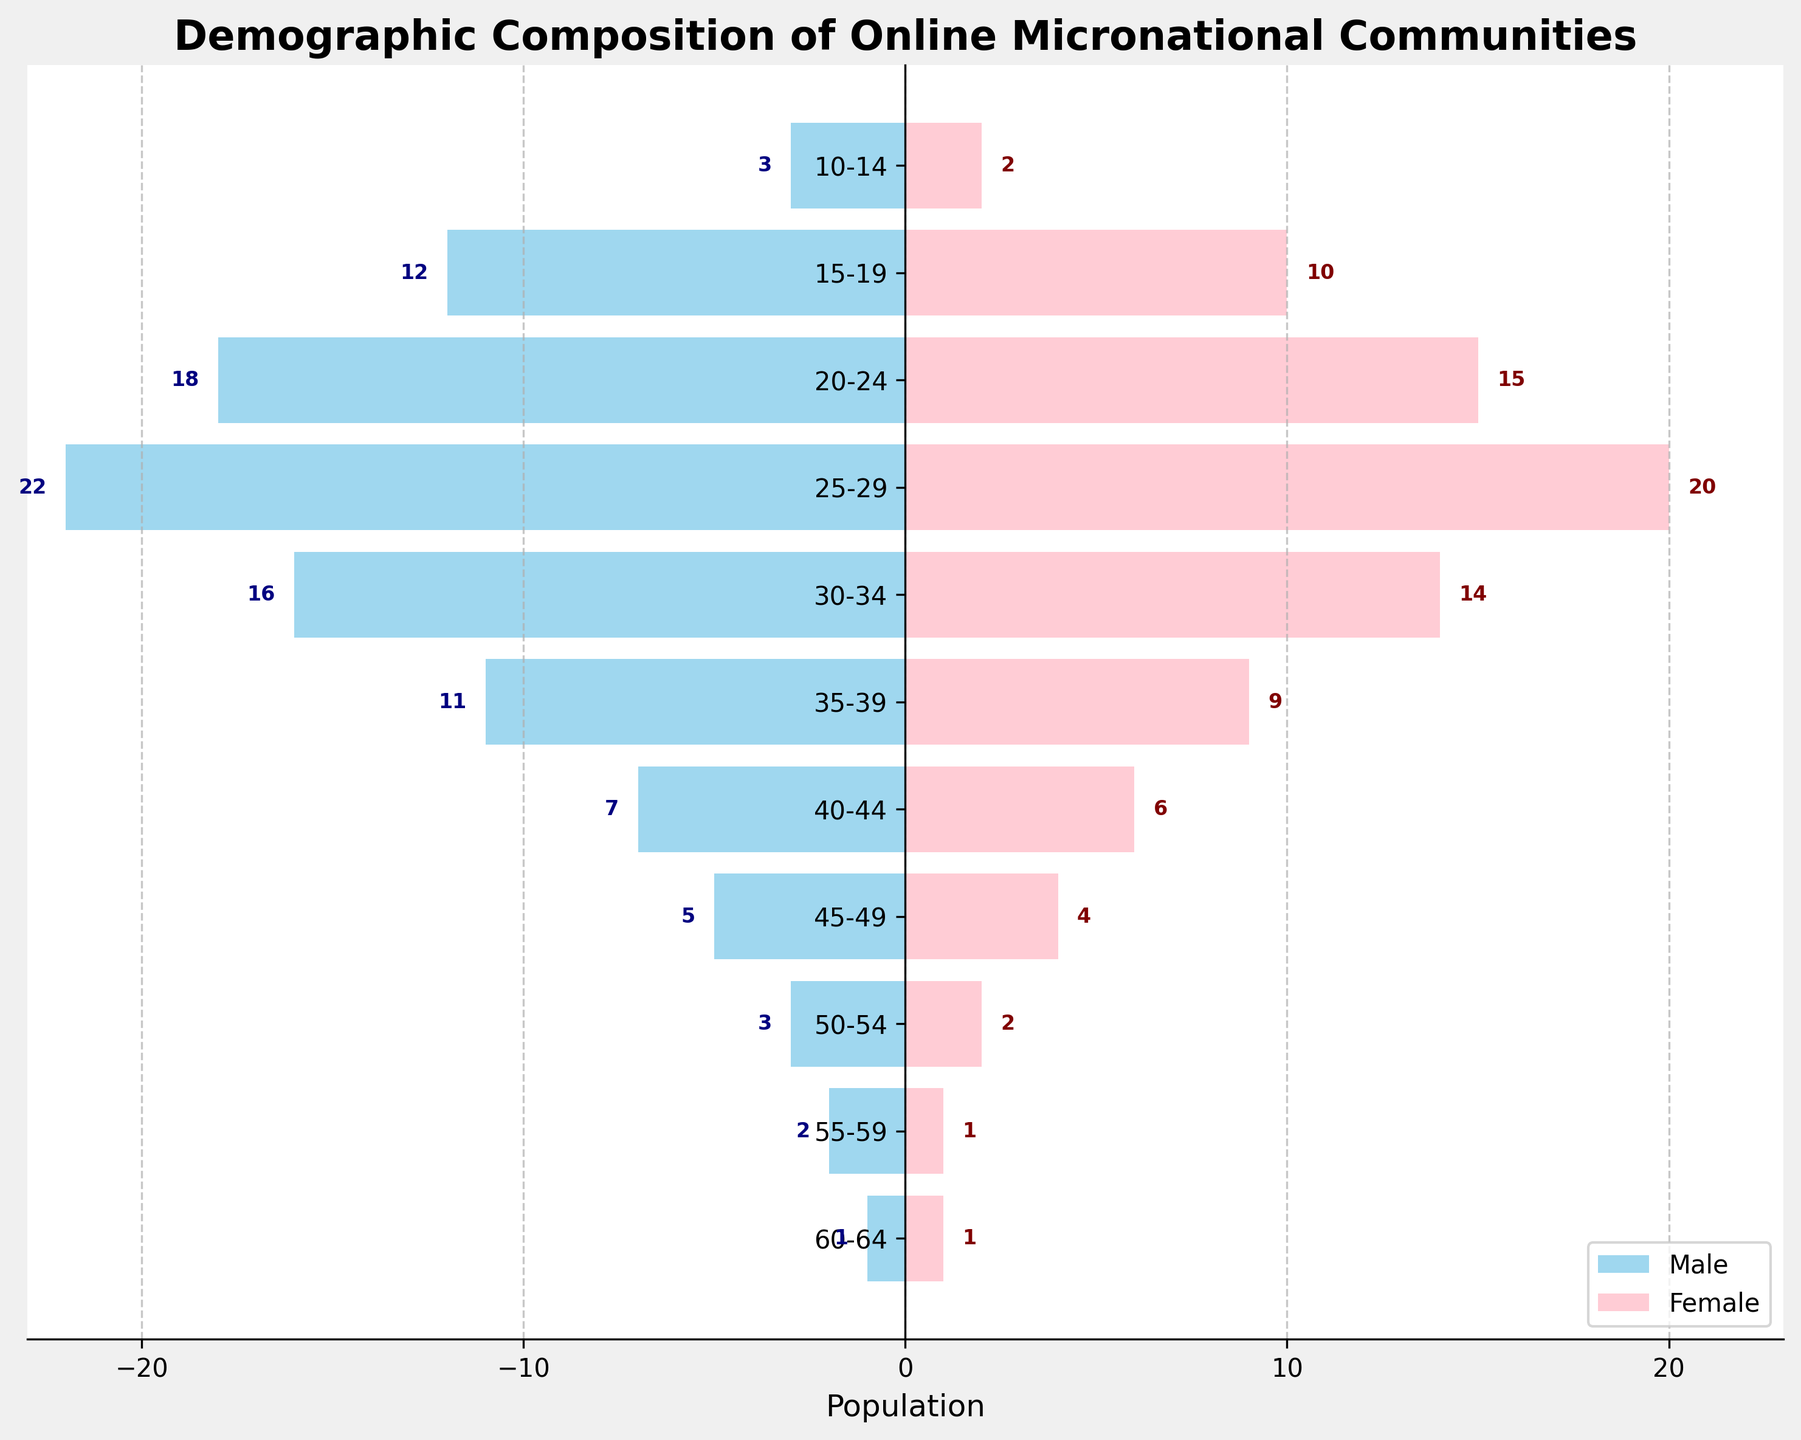What is the title of the plot? The title is located at the top of the plot and is usually in a larger, bold font. In this case, it reads "Demographic Composition of Online Micronational Communities".
Answer: Demographic Composition of Online Micronational Communities What are the age groups with the highest male and female populations? Scan across the plot to compare the lengths of the bars for both male and female. The age group with the longest bar for both male and female is "25-29".
Answer: 25-29 Which gender has a larger population in the 30-34 age group? Compare the lengths of the bars for males and females within the 30-34 age group. The bar for males is slightly longer, indicating a larger population.
Answer: Male How many males are there in the 45-49 age group? Find the bar corresponding to the 45-49 age group on the male side (to the left) and read the text label attached to it. The label shows "5".
Answer: 5 What is the total population in the 20-24 age group? Add the values for both males (18) and females (15) in the 20-24 age group. So, 18 + 15 equals 33.
Answer: 33 What age group has the smallest population, and what is that population? Compare the lengths of bars across all age groups for both males and females. The shortest bars correspond to the 60-64 age group with both having a population of 1.
Answer: 60-64, 2 Which age group has a greater disparity between the number of males and females? Calculate the differences between males' and females' populations for each age group. The 25-29 age group has a population of 22 males and 20 females, a difference of 2, which is the largest among the age groups.
Answer: 25-29 What is the average population of females in the age groups from 30-34 to 45-49? The populations for the age groups 30-34, 35-39, 40-44, and 45-49 are 14, 9, 6, and 4 respectively. Add these together (14 + 9 + 6 + 4 = 33) and divide by the number of groups (4). The average is 33 / 4 = 8.25.
Answer: 8.25 